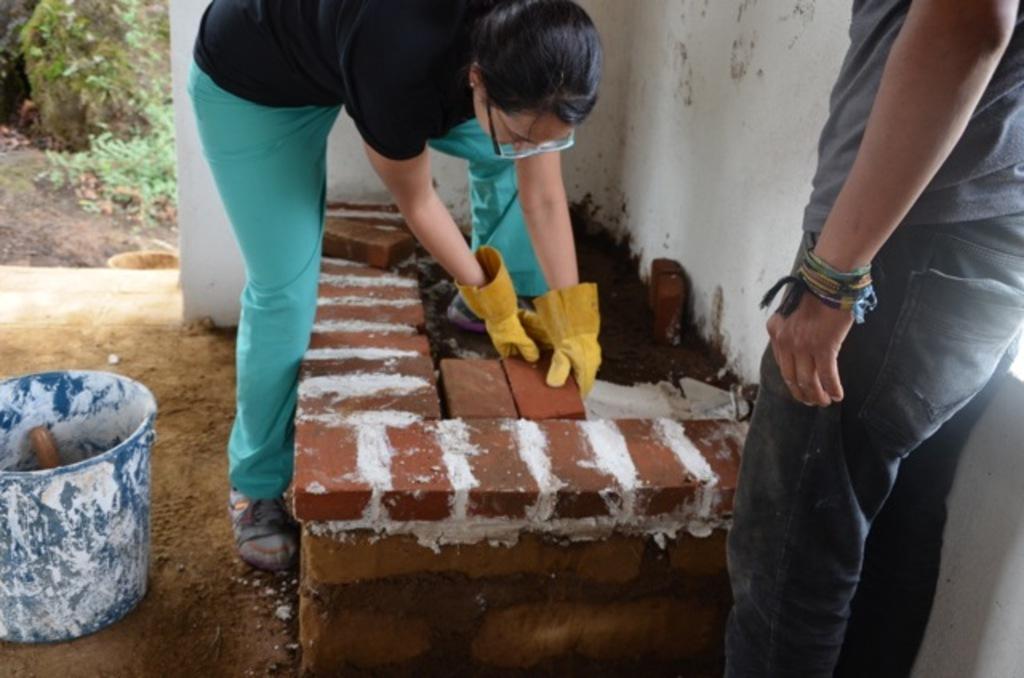Describe this image in one or two sentences. In this image we can see a person standing and holding a brick. At the bottom there is a brick wall. On the right there is a man standing. On the left there is a bucket. In the background there are plants. 